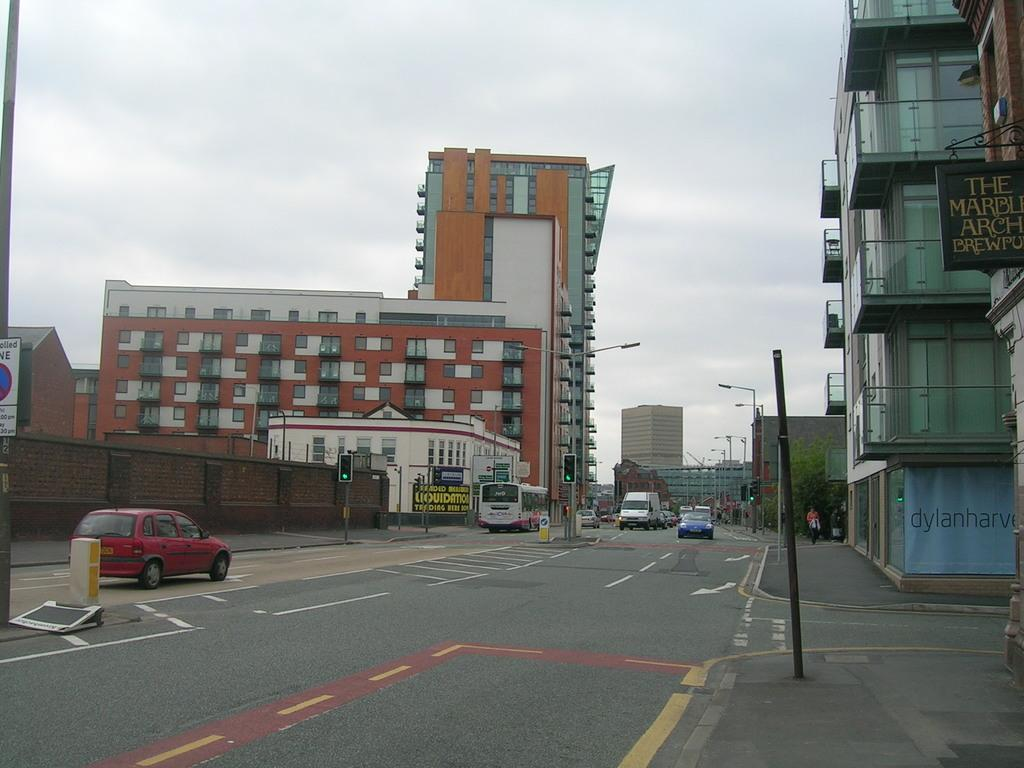What can be seen on the road in the image? There are vehicles on the road in the image. What objects are present in the image besides the vehicles? There are poles, boards, traffic signals, lights, buildings, and leaves in the image. What type of infrastructure is present in the image? The image shows poles, traffic signals, and lights, which are part of the infrastructure. What is visible in the background of the image? The sky is visible in the background of the image. What advertisement can be seen on the side of the building in the image? There is no advertisement visible on the side of the building in the image. What is the grandmother doing in the image? There is no grandmother present in the image. 